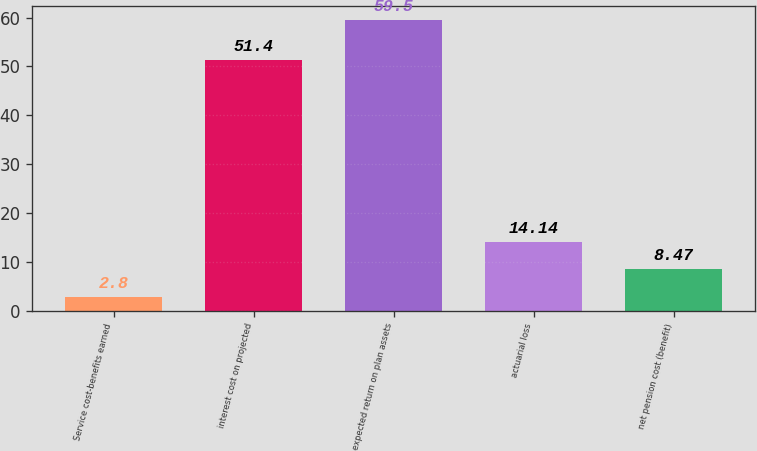Convert chart. <chart><loc_0><loc_0><loc_500><loc_500><bar_chart><fcel>Service cost-benefits earned<fcel>interest cost on projected<fcel>expected return on plan assets<fcel>actuarial loss<fcel>net pension cost (benefit)<nl><fcel>2.8<fcel>51.4<fcel>59.5<fcel>14.14<fcel>8.47<nl></chart> 